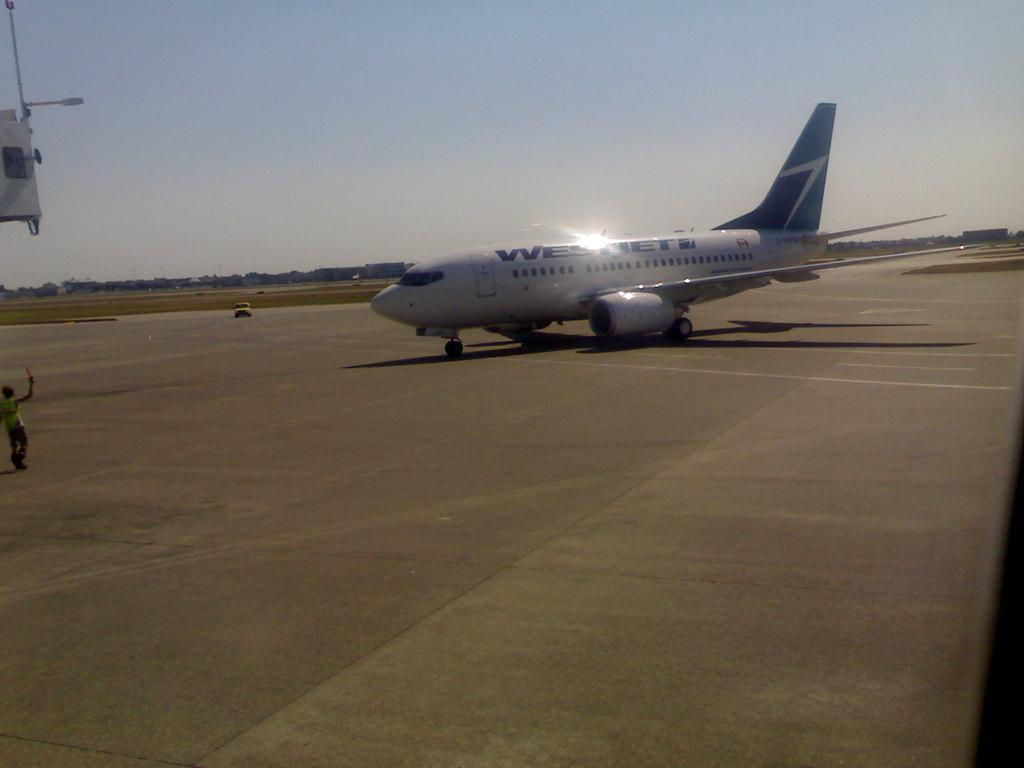<image>
Write a terse but informative summary of the picture. a West Jet taxiing on a runway toward a gate 